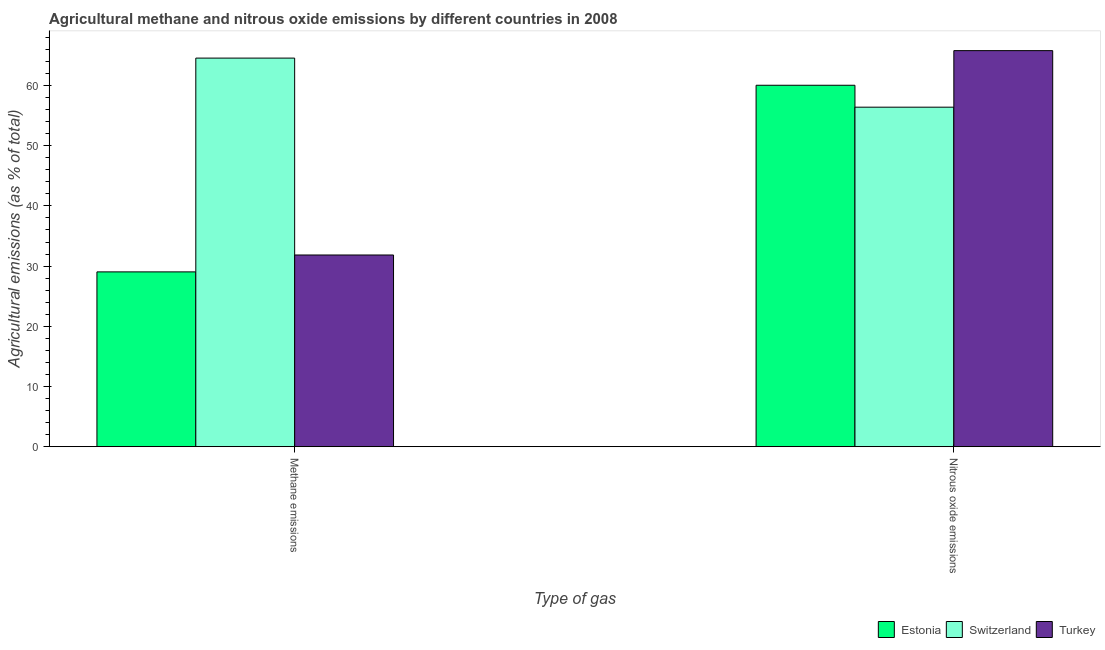How many groups of bars are there?
Provide a succinct answer. 2. Are the number of bars per tick equal to the number of legend labels?
Provide a short and direct response. Yes. Are the number of bars on each tick of the X-axis equal?
Provide a succinct answer. Yes. How many bars are there on the 2nd tick from the left?
Your response must be concise. 3. How many bars are there on the 1st tick from the right?
Keep it short and to the point. 3. What is the label of the 2nd group of bars from the left?
Your response must be concise. Nitrous oxide emissions. What is the amount of nitrous oxide emissions in Estonia?
Provide a short and direct response. 60.05. Across all countries, what is the maximum amount of nitrous oxide emissions?
Offer a terse response. 65.8. Across all countries, what is the minimum amount of nitrous oxide emissions?
Offer a very short reply. 56.4. In which country was the amount of methane emissions maximum?
Offer a terse response. Switzerland. In which country was the amount of methane emissions minimum?
Provide a succinct answer. Estonia. What is the total amount of methane emissions in the graph?
Keep it short and to the point. 125.45. What is the difference between the amount of nitrous oxide emissions in Turkey and that in Switzerland?
Offer a very short reply. 9.4. What is the difference between the amount of methane emissions in Switzerland and the amount of nitrous oxide emissions in Turkey?
Provide a short and direct response. -1.24. What is the average amount of methane emissions per country?
Ensure brevity in your answer.  41.82. What is the difference between the amount of nitrous oxide emissions and amount of methane emissions in Estonia?
Your response must be concise. 31. In how many countries, is the amount of methane emissions greater than 38 %?
Provide a succinct answer. 1. What is the ratio of the amount of methane emissions in Turkey to that in Estonia?
Your answer should be very brief. 1.1. In how many countries, is the amount of methane emissions greater than the average amount of methane emissions taken over all countries?
Give a very brief answer. 1. What does the 3rd bar from the left in Methane emissions represents?
Keep it short and to the point. Turkey. What does the 2nd bar from the right in Nitrous oxide emissions represents?
Make the answer very short. Switzerland. How many bars are there?
Offer a terse response. 6. How many countries are there in the graph?
Give a very brief answer. 3. What is the difference between two consecutive major ticks on the Y-axis?
Provide a short and direct response. 10. Are the values on the major ticks of Y-axis written in scientific E-notation?
Provide a short and direct response. No. Does the graph contain any zero values?
Your answer should be compact. No. Where does the legend appear in the graph?
Your answer should be very brief. Bottom right. What is the title of the graph?
Ensure brevity in your answer.  Agricultural methane and nitrous oxide emissions by different countries in 2008. Does "Korea (Republic)" appear as one of the legend labels in the graph?
Provide a short and direct response. No. What is the label or title of the X-axis?
Make the answer very short. Type of gas. What is the label or title of the Y-axis?
Ensure brevity in your answer.  Agricultural emissions (as % of total). What is the Agricultural emissions (as % of total) in Estonia in Methane emissions?
Offer a very short reply. 29.04. What is the Agricultural emissions (as % of total) of Switzerland in Methane emissions?
Provide a succinct answer. 64.56. What is the Agricultural emissions (as % of total) of Turkey in Methane emissions?
Give a very brief answer. 31.85. What is the Agricultural emissions (as % of total) in Estonia in Nitrous oxide emissions?
Your answer should be compact. 60.05. What is the Agricultural emissions (as % of total) in Switzerland in Nitrous oxide emissions?
Ensure brevity in your answer.  56.4. What is the Agricultural emissions (as % of total) of Turkey in Nitrous oxide emissions?
Make the answer very short. 65.8. Across all Type of gas, what is the maximum Agricultural emissions (as % of total) in Estonia?
Provide a short and direct response. 60.05. Across all Type of gas, what is the maximum Agricultural emissions (as % of total) of Switzerland?
Make the answer very short. 64.56. Across all Type of gas, what is the maximum Agricultural emissions (as % of total) of Turkey?
Make the answer very short. 65.8. Across all Type of gas, what is the minimum Agricultural emissions (as % of total) of Estonia?
Give a very brief answer. 29.04. Across all Type of gas, what is the minimum Agricultural emissions (as % of total) of Switzerland?
Keep it short and to the point. 56.4. Across all Type of gas, what is the minimum Agricultural emissions (as % of total) in Turkey?
Offer a very short reply. 31.85. What is the total Agricultural emissions (as % of total) in Estonia in the graph?
Your response must be concise. 89.09. What is the total Agricultural emissions (as % of total) of Switzerland in the graph?
Offer a terse response. 120.96. What is the total Agricultural emissions (as % of total) of Turkey in the graph?
Provide a short and direct response. 97.65. What is the difference between the Agricultural emissions (as % of total) of Estonia in Methane emissions and that in Nitrous oxide emissions?
Keep it short and to the point. -31. What is the difference between the Agricultural emissions (as % of total) of Switzerland in Methane emissions and that in Nitrous oxide emissions?
Make the answer very short. 8.15. What is the difference between the Agricultural emissions (as % of total) in Turkey in Methane emissions and that in Nitrous oxide emissions?
Your response must be concise. -33.95. What is the difference between the Agricultural emissions (as % of total) in Estonia in Methane emissions and the Agricultural emissions (as % of total) in Switzerland in Nitrous oxide emissions?
Give a very brief answer. -27.36. What is the difference between the Agricultural emissions (as % of total) of Estonia in Methane emissions and the Agricultural emissions (as % of total) of Turkey in Nitrous oxide emissions?
Your response must be concise. -36.76. What is the difference between the Agricultural emissions (as % of total) in Switzerland in Methane emissions and the Agricultural emissions (as % of total) in Turkey in Nitrous oxide emissions?
Give a very brief answer. -1.24. What is the average Agricultural emissions (as % of total) in Estonia per Type of gas?
Give a very brief answer. 44.54. What is the average Agricultural emissions (as % of total) in Switzerland per Type of gas?
Make the answer very short. 60.48. What is the average Agricultural emissions (as % of total) in Turkey per Type of gas?
Keep it short and to the point. 48.82. What is the difference between the Agricultural emissions (as % of total) in Estonia and Agricultural emissions (as % of total) in Switzerland in Methane emissions?
Provide a succinct answer. -35.52. What is the difference between the Agricultural emissions (as % of total) of Estonia and Agricultural emissions (as % of total) of Turkey in Methane emissions?
Offer a terse response. -2.81. What is the difference between the Agricultural emissions (as % of total) in Switzerland and Agricultural emissions (as % of total) in Turkey in Methane emissions?
Your response must be concise. 32.71. What is the difference between the Agricultural emissions (as % of total) in Estonia and Agricultural emissions (as % of total) in Switzerland in Nitrous oxide emissions?
Offer a very short reply. 3.64. What is the difference between the Agricultural emissions (as % of total) of Estonia and Agricultural emissions (as % of total) of Turkey in Nitrous oxide emissions?
Your response must be concise. -5.75. What is the difference between the Agricultural emissions (as % of total) of Switzerland and Agricultural emissions (as % of total) of Turkey in Nitrous oxide emissions?
Your answer should be very brief. -9.4. What is the ratio of the Agricultural emissions (as % of total) in Estonia in Methane emissions to that in Nitrous oxide emissions?
Offer a very short reply. 0.48. What is the ratio of the Agricultural emissions (as % of total) in Switzerland in Methane emissions to that in Nitrous oxide emissions?
Ensure brevity in your answer.  1.14. What is the ratio of the Agricultural emissions (as % of total) in Turkey in Methane emissions to that in Nitrous oxide emissions?
Your answer should be very brief. 0.48. What is the difference between the highest and the second highest Agricultural emissions (as % of total) in Estonia?
Offer a terse response. 31. What is the difference between the highest and the second highest Agricultural emissions (as % of total) in Switzerland?
Provide a short and direct response. 8.15. What is the difference between the highest and the second highest Agricultural emissions (as % of total) in Turkey?
Your answer should be very brief. 33.95. What is the difference between the highest and the lowest Agricultural emissions (as % of total) in Estonia?
Your answer should be very brief. 31. What is the difference between the highest and the lowest Agricultural emissions (as % of total) in Switzerland?
Your answer should be compact. 8.15. What is the difference between the highest and the lowest Agricultural emissions (as % of total) in Turkey?
Your response must be concise. 33.95. 